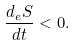<formula> <loc_0><loc_0><loc_500><loc_500>\frac { d _ { e } S } { d t } < 0 .</formula> 